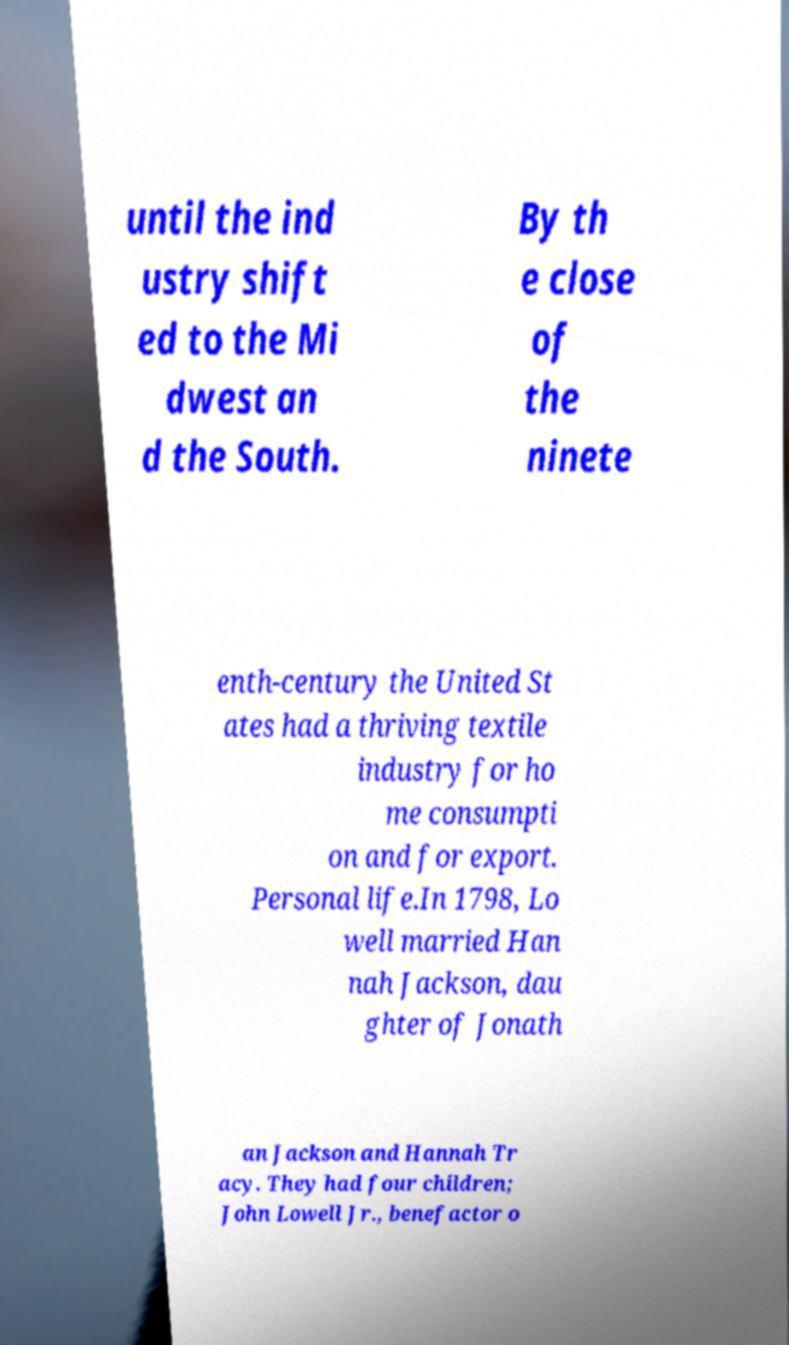Could you extract and type out the text from this image? until the ind ustry shift ed to the Mi dwest an d the South. By th e close of the ninete enth-century the United St ates had a thriving textile industry for ho me consumpti on and for export. Personal life.In 1798, Lo well married Han nah Jackson, dau ghter of Jonath an Jackson and Hannah Tr acy. They had four children; John Lowell Jr., benefactor o 